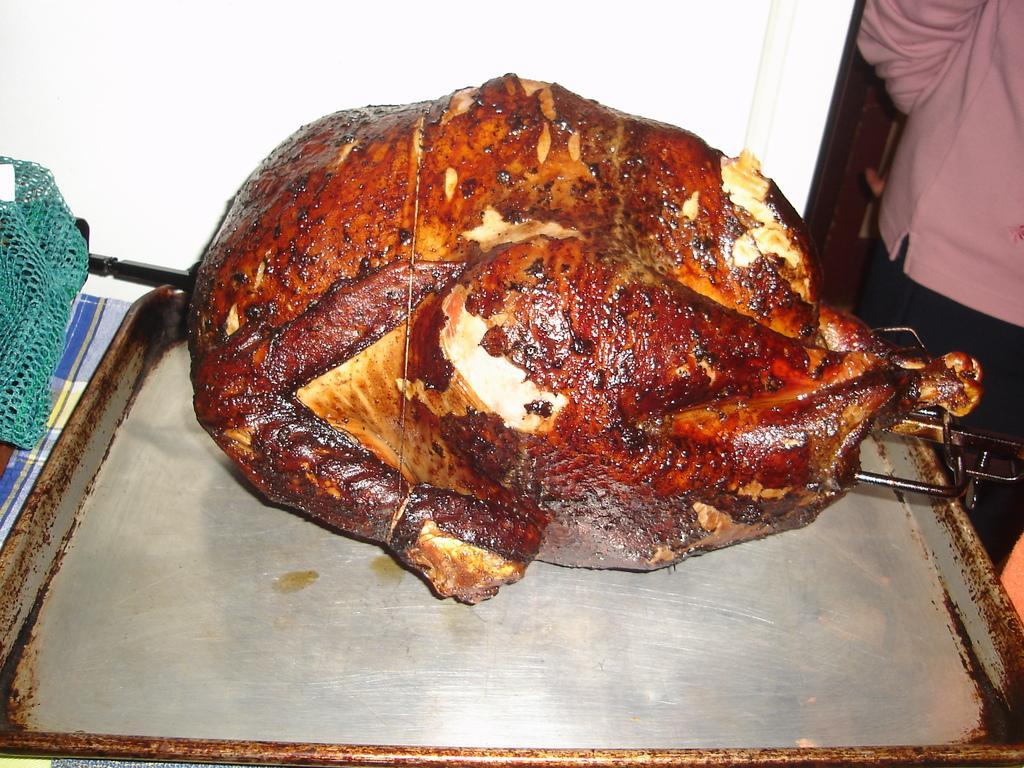Describe this image in one or two sentences. In this image we can see a food item in a tray. In the background of the image there is wall. To the right side of the image there is a person standing. 